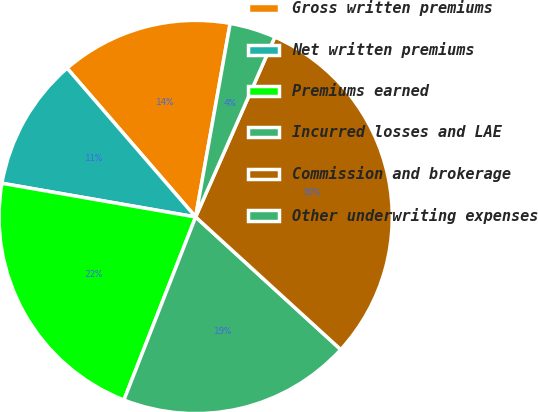Convert chart to OTSL. <chart><loc_0><loc_0><loc_500><loc_500><pie_chart><fcel>Gross written premiums<fcel>Net written premiums<fcel>Premiums earned<fcel>Incurred losses and LAE<fcel>Commission and brokerage<fcel>Other underwriting expenses<nl><fcel>14.15%<fcel>10.92%<fcel>21.8%<fcel>19.16%<fcel>30.19%<fcel>3.79%<nl></chart> 